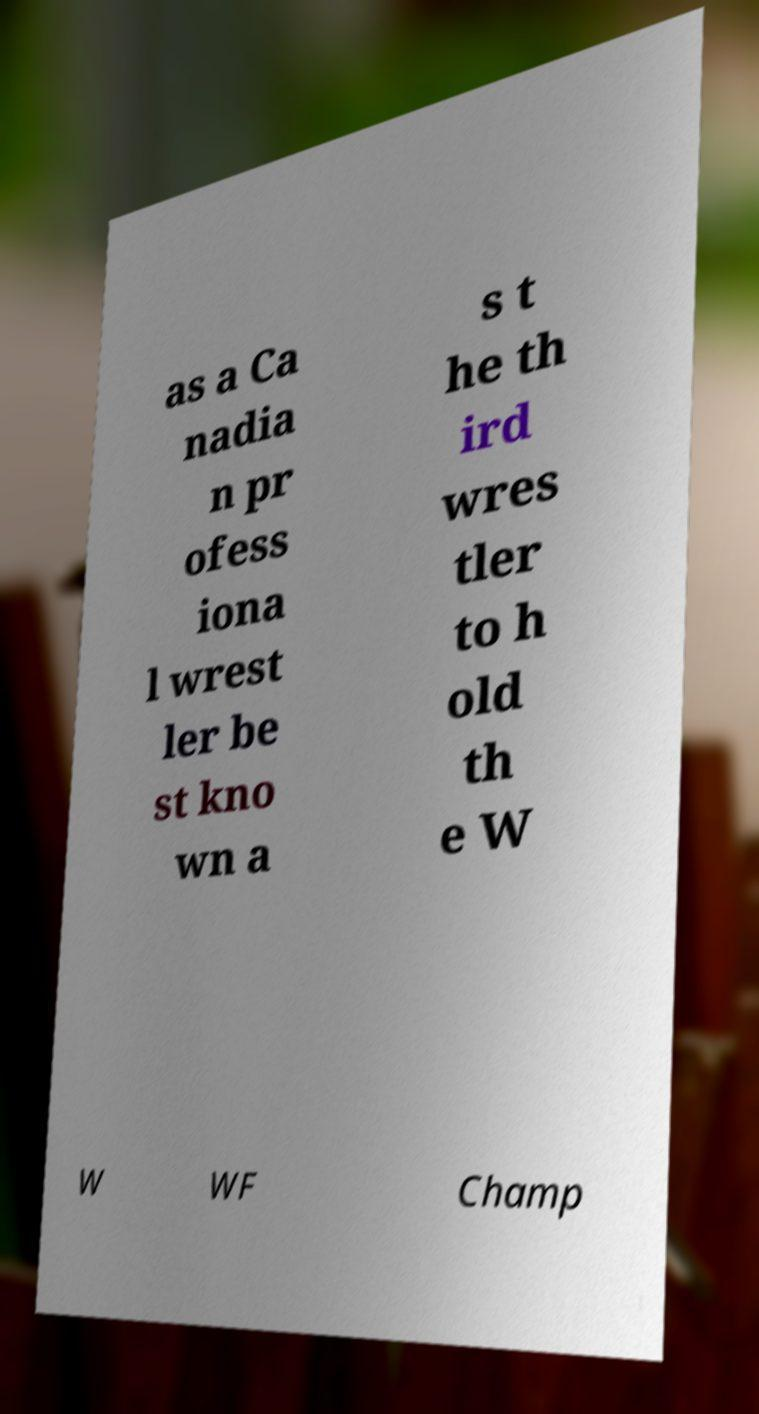I need the written content from this picture converted into text. Can you do that? as a Ca nadia n pr ofess iona l wrest ler be st kno wn a s t he th ird wres tler to h old th e W W WF Champ 